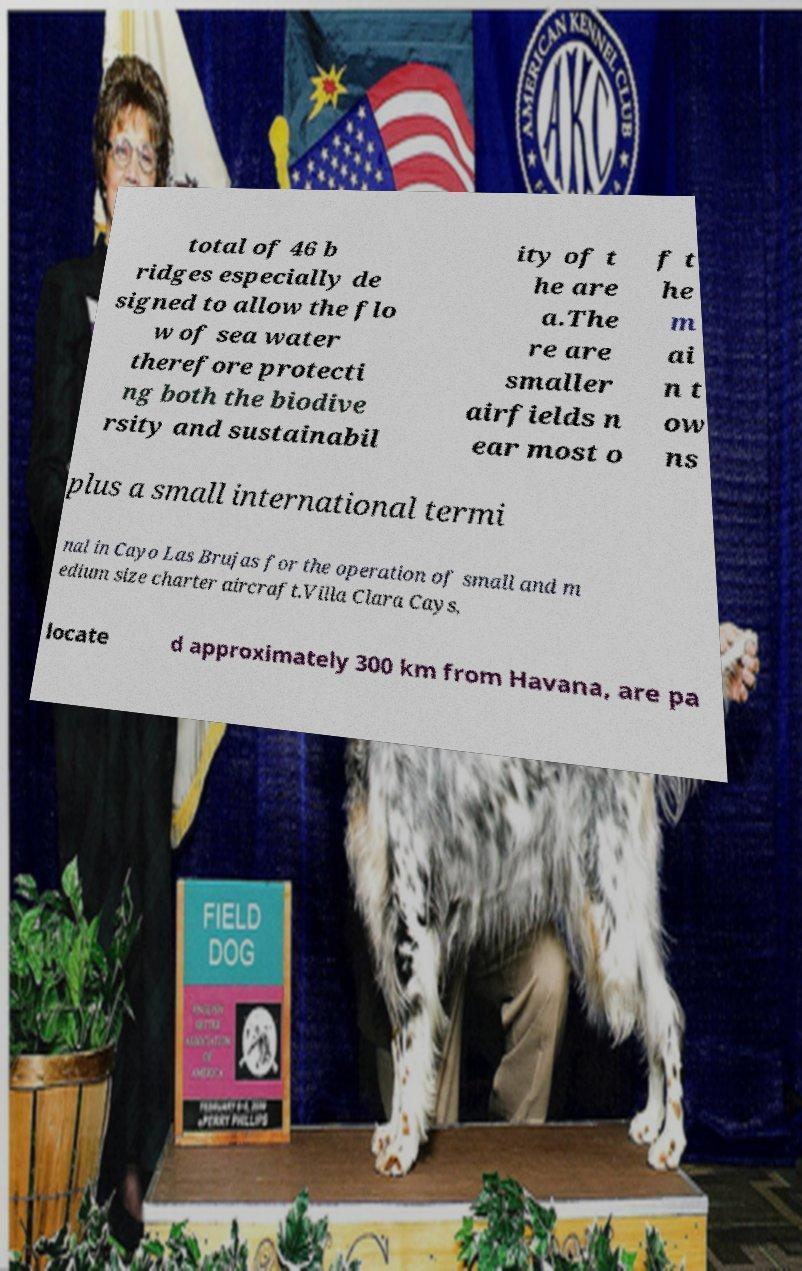Can you accurately transcribe the text from the provided image for me? total of 46 b ridges especially de signed to allow the flo w of sea water therefore protecti ng both the biodive rsity and sustainabil ity of t he are a.The re are smaller airfields n ear most o f t he m ai n t ow ns plus a small international termi nal in Cayo Las Brujas for the operation of small and m edium size charter aircraft.Villa Clara Cays, locate d approximately 300 km from Havana, are pa 